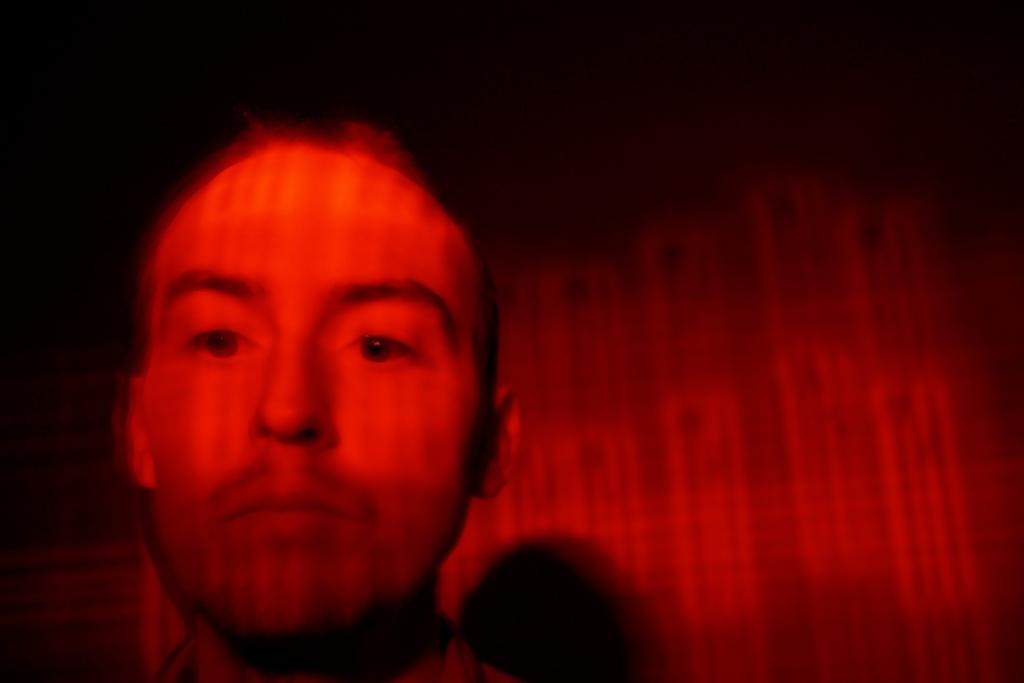What is the main subject of the image? There is a person in the image. Can you describe the background of the image? The background of the image is red and black. Can you see a ray moving in the image? There is no ray present in the image. Is there a squirrel visible in the image? There is no squirrel present in the image. 